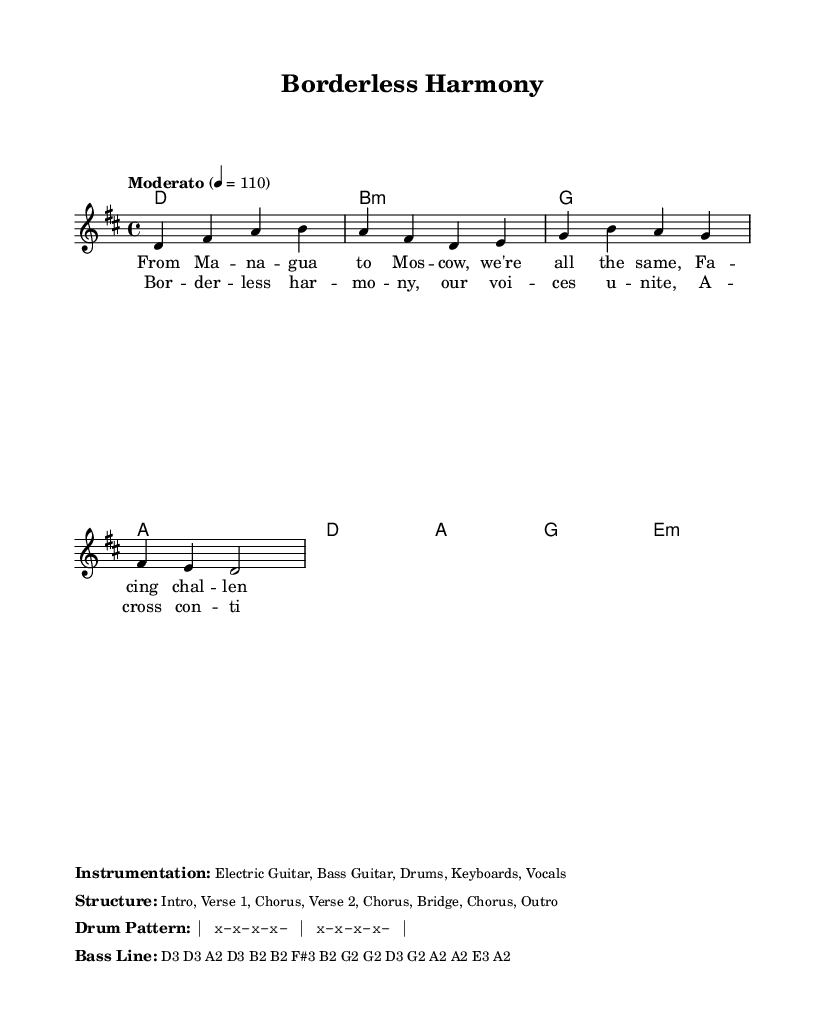What is the key signature of this music? The key signature is D major, which has two sharps (F# and C#). This can be deduced from the global settings in the code where it states \key d \major.
Answer: D major What is the time signature of this music? The time signature is 4/4, indicated by the \time 4/4 setting in the global parameters. This means there are four beats in each measure.
Answer: 4/4 What is the tempo of this piece? The tempo is marked as Moderato, set to 110 beats per minute (BPM), as shown in the tempo directive of the global settings.
Answer: Moderato 4 = 110 How many verses are in the song? There are two verses in the song as indicated by the structure provided, which mentions "Verse 1" and "Verse 2".
Answer: Two What instruments are used in this composition? The instrumentation includes Electric Guitar, Bass Guitar, Drums, Keyboards, and Vocals, detailed in the markup section that describes the instrumentation.
Answer: Electric Guitar, Bass Guitar, Drums, Keyboards, Vocals How is the chord structure composed? The chord structure consists of the following chords: D, B minor, G, A, D, A, G, and E minor. This is identified from the harmonies section of the code that defines the chord progression.
Answer: D, B minor, G, A, D, A, G, E minor What does the chorus focus on? The chorus emphasizes "Borderless harmony" and the unity of voices across continents, as shown in the lyrical content detailed in the chorus section of the code.
Answer: Borderless harmony 